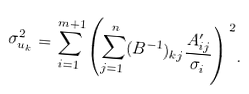Convert formula to latex. <formula><loc_0><loc_0><loc_500><loc_500>\sigma _ { u _ { k } } ^ { 2 } = \sum _ { i = 1 } ^ { m + 1 } \left ( \sum _ { j = 1 } ^ { n } ( B ^ { - 1 } ) _ { k j } \frac { A ^ { \prime } _ { i j } } { \sigma _ { i } } \right ) ^ { 2 } .</formula> 